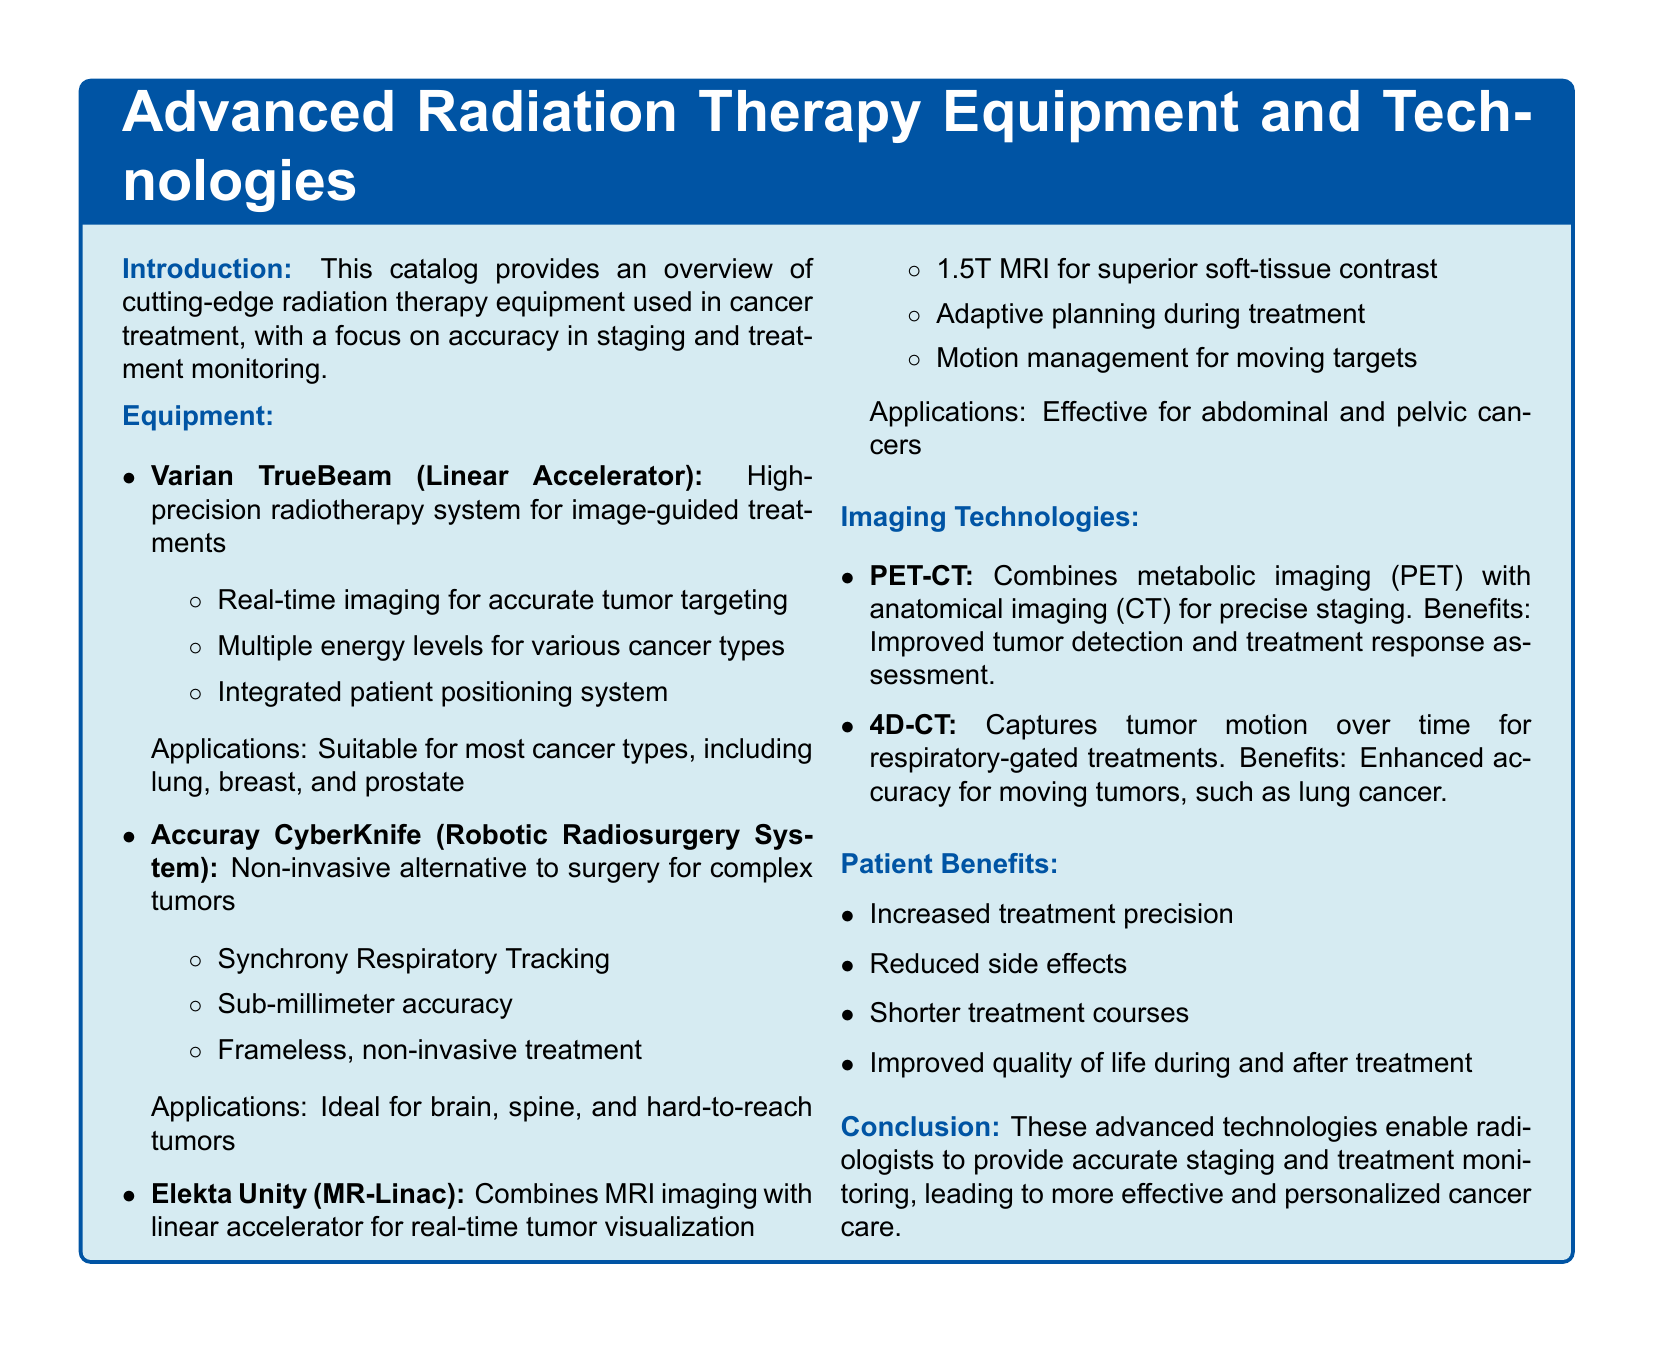what is the purpose of the Varian TrueBeam? The Varian TrueBeam is a high-precision radiotherapy system for image-guided treatments.
Answer: image-guided treatments what type of cancer is the CyberKnife ideal for? The CyberKnife is ideal for brain, spine, and hard-to-reach tumors.
Answer: brain, spine, and hard-to-reach tumors what technology does Elekta Unity combine with linear accelerator? The Elekta Unity combines MRI imaging with linear accelerator for real-time tumor visualization.
Answer: MRI imaging what is the benefit of PET-CT technology? The benefit of PET-CT is improved tumor detection and treatment response assessment.
Answer: improved tumor detection what is the main advantage of using 4D-CT? The main advantage of using 4D-CT is enhanced accuracy for moving tumors, such as lung cancer.
Answer: enhanced accuracy for moving tumors how does radiation therapy benefit patients? Radiation therapy benefits patients by increasing treatment precision and reducing side effects.
Answer: increased treatment precision what is the main theme of the catalog? The main theme of the catalog is providing an overview of advanced radiation therapy equipment and technologies.
Answer: advanced radiation therapy equipment how does the Elekta Unity enhance treatment planning? The Elekta Unity enhances treatment planning through adaptive planning during treatment.
Answer: adaptive planning during treatment 